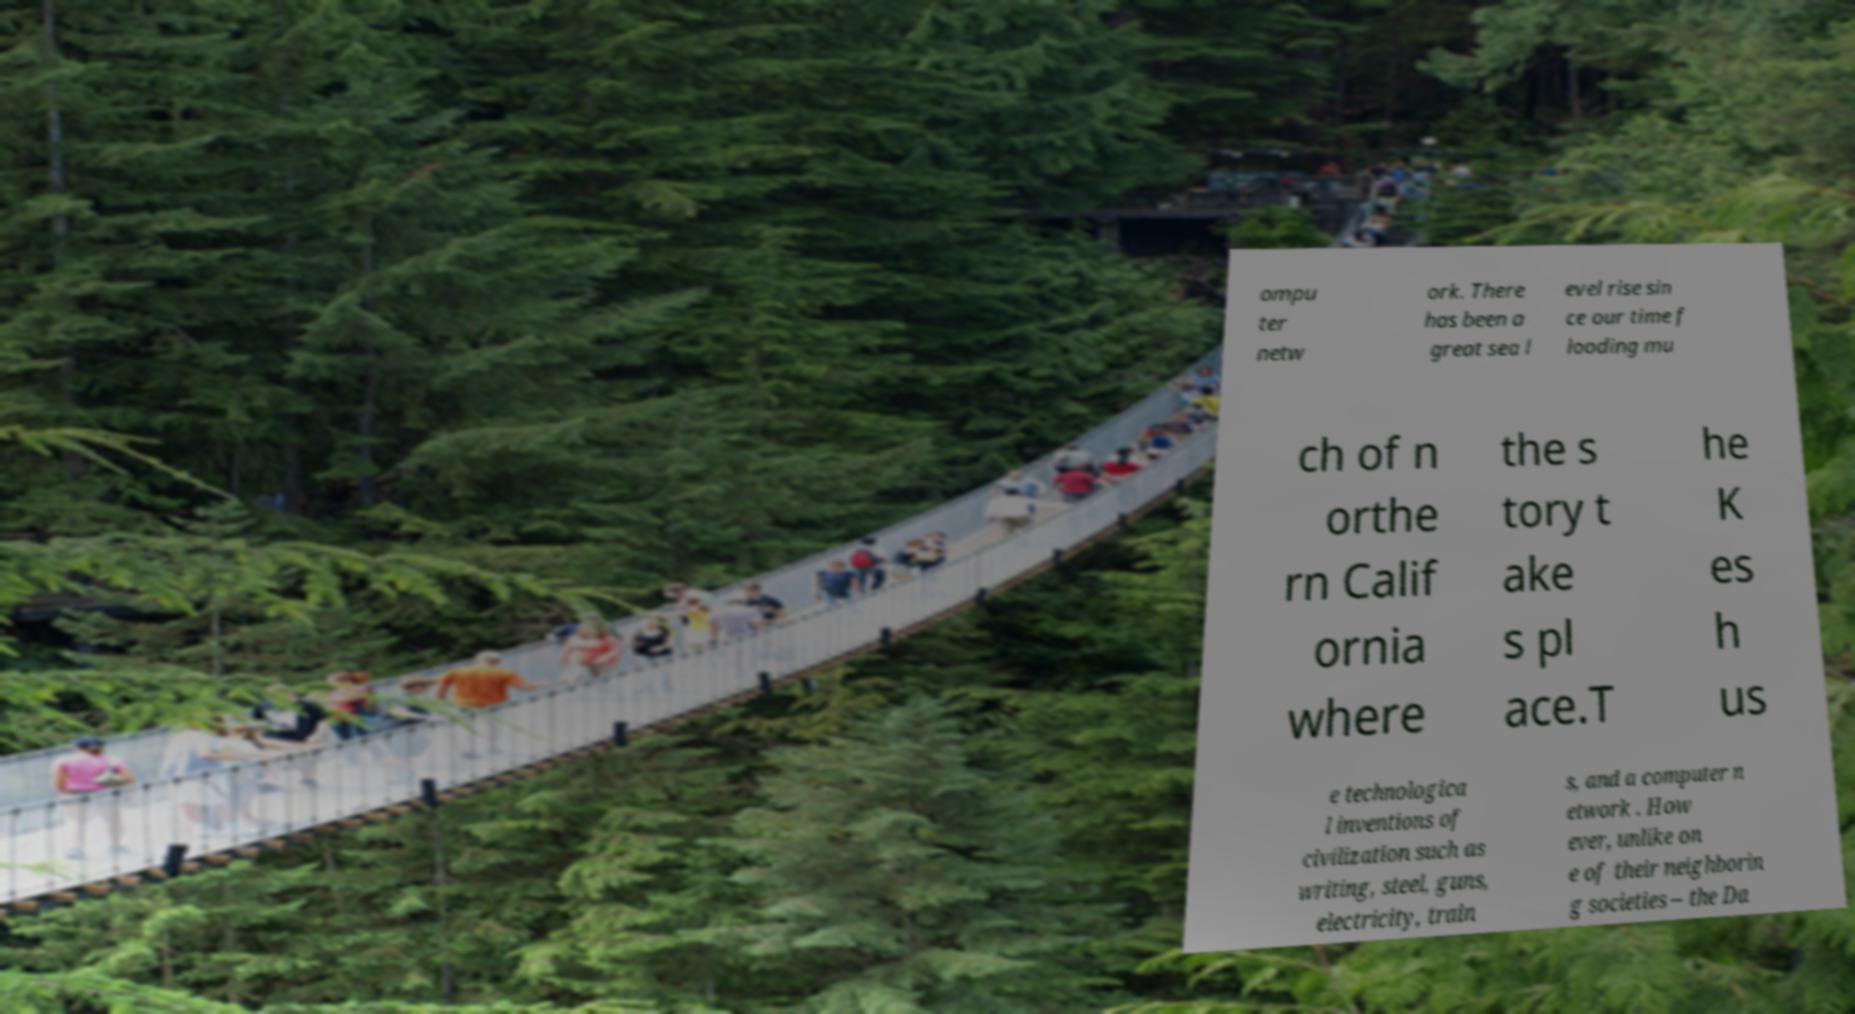Could you assist in decoding the text presented in this image and type it out clearly? ompu ter netw ork. There has been a great sea l evel rise sin ce our time f looding mu ch of n orthe rn Calif ornia where the s tory t ake s pl ace.T he K es h us e technologica l inventions of civilization such as writing, steel, guns, electricity, train s, and a computer n etwork . How ever, unlike on e of their neighborin g societies – the Da 